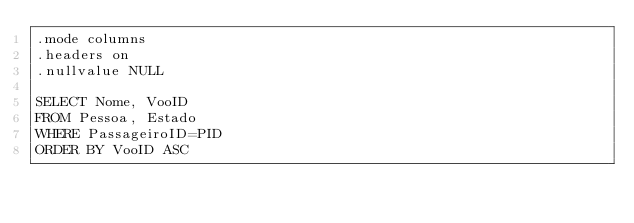Convert code to text. <code><loc_0><loc_0><loc_500><loc_500><_SQL_>.mode columns
.headers on
.nullvalue NULL 

SELECT Nome, VooID
FROM Pessoa, Estado
WHERE PassageiroID=PID
ORDER BY VooID ASC</code> 